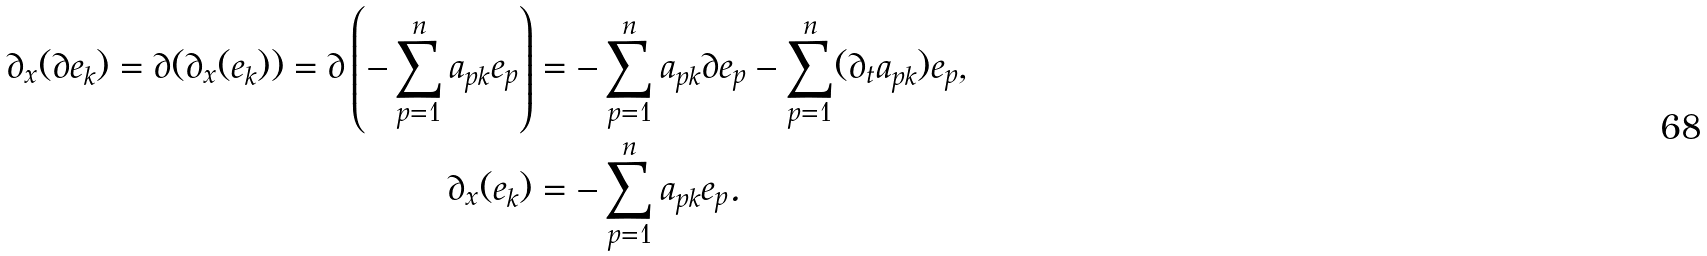<formula> <loc_0><loc_0><loc_500><loc_500>\partial _ { x } ( \partial e _ { k } ) = \partial ( \partial _ { x } ( e _ { k } ) ) = \partial \left ( - \sum _ { p = 1 } ^ { n } a _ { p k } e _ { p } \right ) & = - \sum _ { p = 1 } ^ { n } a _ { p k } \partial e _ { p } - \sum _ { p = 1 } ^ { n } ( \partial _ { t } a _ { p k } ) e _ { p } , \\ \partial _ { x } ( e _ { k } ) & = - \sum _ { p = 1 } ^ { n } a _ { p k } e _ { p } .</formula> 